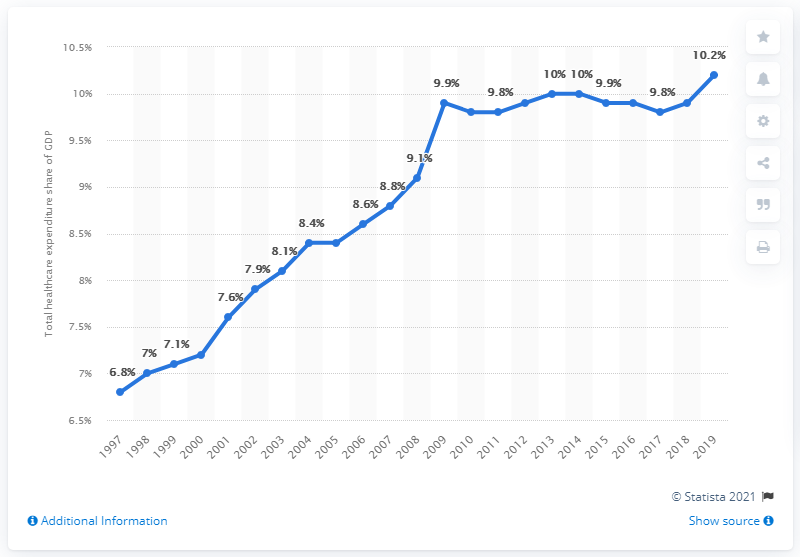Draw attention to some important aspects in this diagram. The UK's healthcare expenditure in 2019 accounted for 10.2% of the country's Gross Domestic Product. In 1997, the percentage of healthcare spending in the UK was 6.8%. 